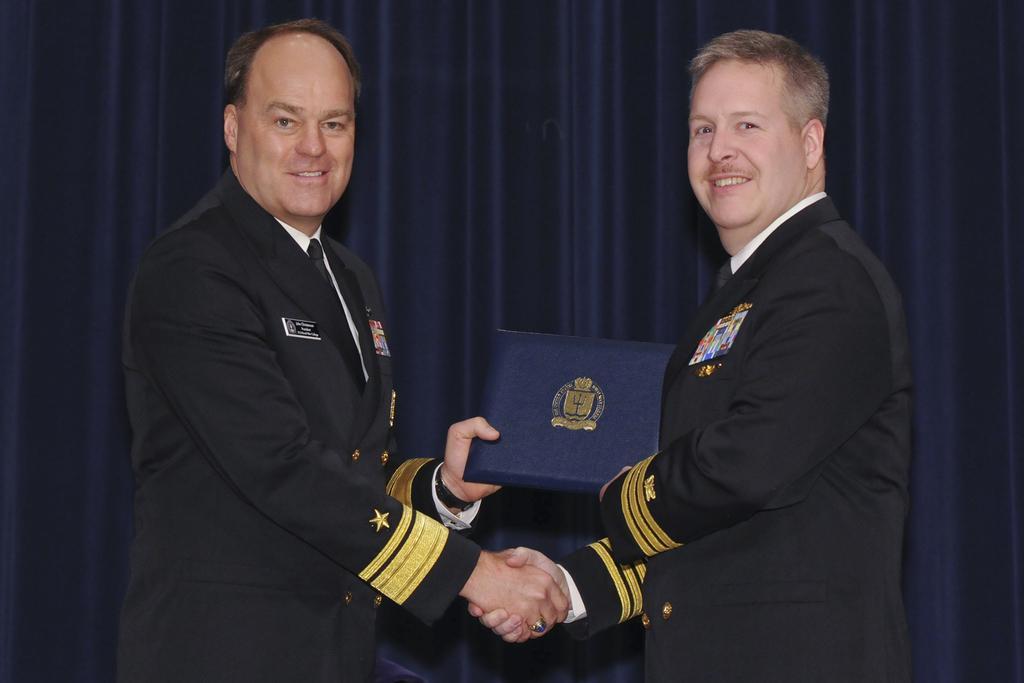How would you summarize this image in a sentence or two? As we can see in the image there are two people and curtain. The man over here is holding a book. 